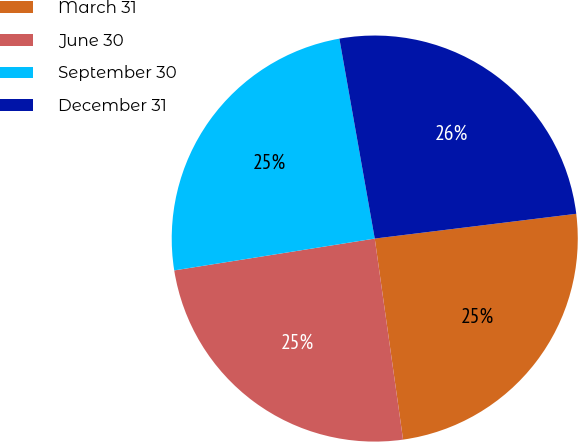<chart> <loc_0><loc_0><loc_500><loc_500><pie_chart><fcel>March 31<fcel>June 30<fcel>September 30<fcel>December 31<nl><fcel>24.72%<fcel>24.72%<fcel>24.72%<fcel>25.84%<nl></chart> 